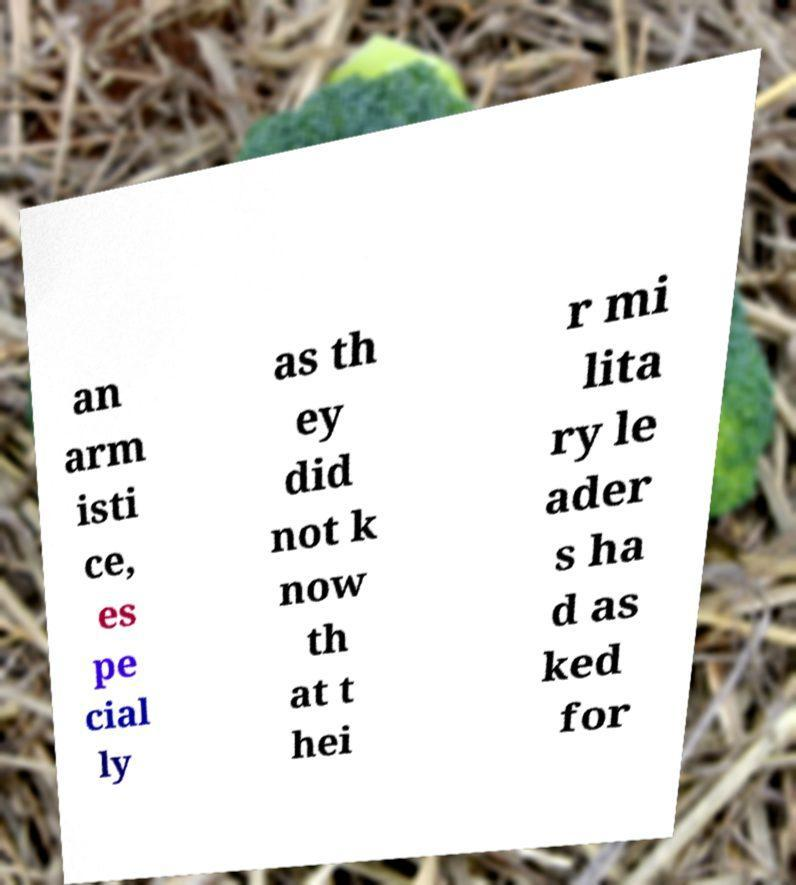Could you assist in decoding the text presented in this image and type it out clearly? an arm isti ce, es pe cial ly as th ey did not k now th at t hei r mi lita ry le ader s ha d as ked for 